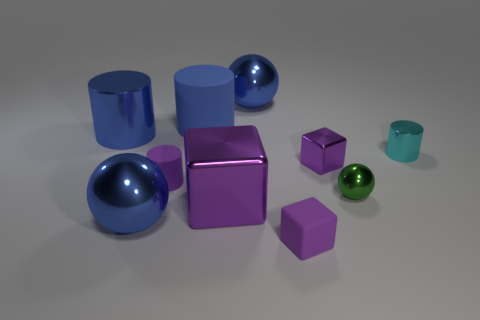The large blue sphere left of the big ball behind the matte cylinder in front of the small purple metallic cube is made of what material?
Your response must be concise. Metal. Is the number of blue metal balls less than the number of big blue objects?
Keep it short and to the point. Yes. Does the tiny sphere have the same material as the big purple cube?
Provide a succinct answer. Yes. There is a small rubber object that is the same color as the tiny rubber block; what shape is it?
Your answer should be compact. Cylinder. There is a matte cylinder that is behind the large metal cylinder; is its color the same as the small matte block?
Offer a terse response. No. What number of large blue metallic objects are behind the blue shiny sphere behind the green shiny sphere?
Offer a terse response. 0. What color is the metal block that is the same size as the blue metal cylinder?
Offer a very short reply. Purple. There is a large ball that is in front of the large matte cylinder; what is its material?
Your response must be concise. Metal. What is the material of the purple cube that is both on the right side of the large purple cube and in front of the tiny metallic block?
Your response must be concise. Rubber. Is the size of the rubber cylinder that is in front of the blue matte cylinder the same as the big cube?
Provide a succinct answer. No. 